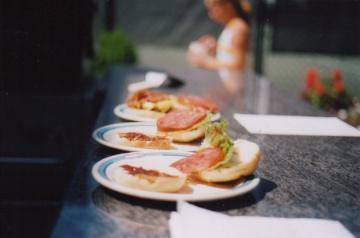How many servings are there?
Give a very brief answer. 3. How many people are there?
Give a very brief answer. 1. How many tomatoes is on the dish?
Give a very brief answer. 1. How many sandwiches can you see?
Give a very brief answer. 1. How many beer bottles have a yellow label on them?
Give a very brief answer. 0. 